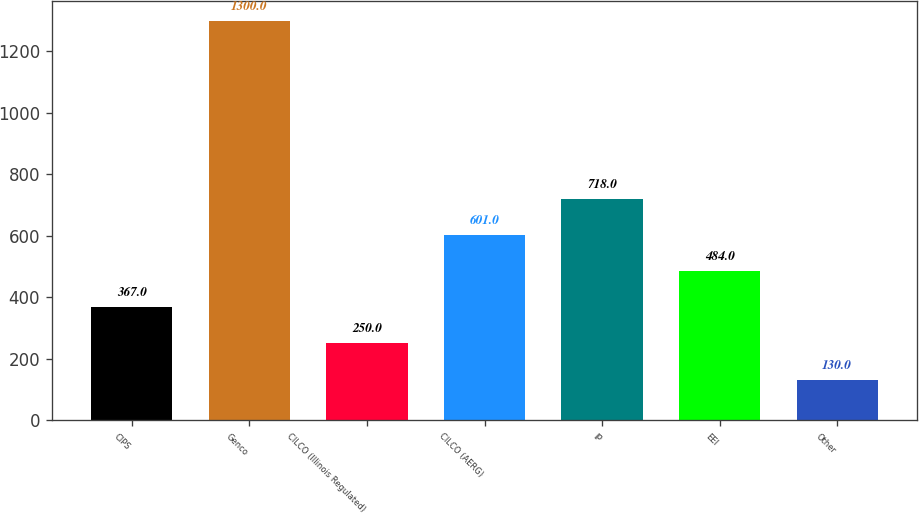Convert chart to OTSL. <chart><loc_0><loc_0><loc_500><loc_500><bar_chart><fcel>CIPS<fcel>Genco<fcel>CILCO (Illinois Regulated)<fcel>CILCO (AERG)<fcel>IP<fcel>EEI<fcel>Other<nl><fcel>367<fcel>1300<fcel>250<fcel>601<fcel>718<fcel>484<fcel>130<nl></chart> 